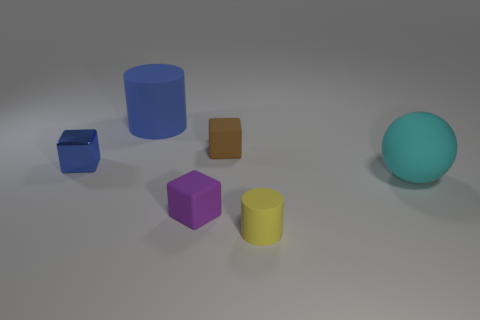Subtract all blue cubes. How many cubes are left? 2 Subtract all yellow cylinders. How many cylinders are left? 1 Add 1 big matte balls. How many objects exist? 7 Subtract 2 cylinders. How many cylinders are left? 0 Subtract all balls. How many objects are left? 5 Subtract all yellow cylinders. How many blue cubes are left? 1 Subtract all blue cylinders. Subtract all metallic blocks. How many objects are left? 4 Add 6 purple objects. How many purple objects are left? 7 Add 3 small brown blocks. How many small brown blocks exist? 4 Subtract 0 brown cylinders. How many objects are left? 6 